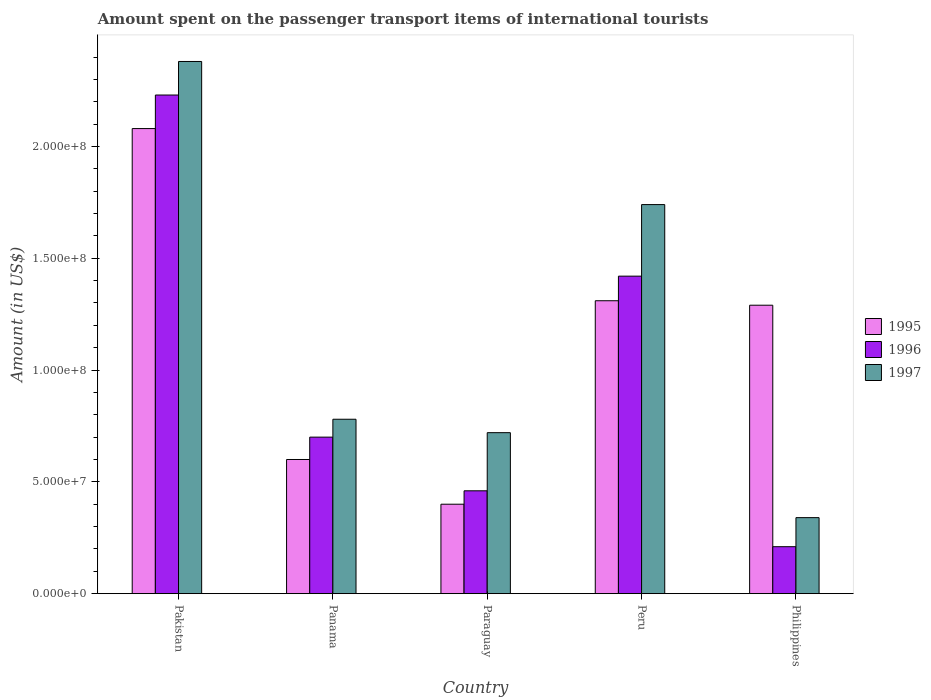How many different coloured bars are there?
Offer a very short reply. 3. Are the number of bars on each tick of the X-axis equal?
Make the answer very short. Yes. What is the label of the 3rd group of bars from the left?
Your response must be concise. Paraguay. In how many cases, is the number of bars for a given country not equal to the number of legend labels?
Your response must be concise. 0. What is the amount spent on the passenger transport items of international tourists in 1996 in Philippines?
Your answer should be very brief. 2.10e+07. Across all countries, what is the maximum amount spent on the passenger transport items of international tourists in 1996?
Ensure brevity in your answer.  2.23e+08. Across all countries, what is the minimum amount spent on the passenger transport items of international tourists in 1996?
Your answer should be very brief. 2.10e+07. What is the total amount spent on the passenger transport items of international tourists in 1995 in the graph?
Ensure brevity in your answer.  5.68e+08. What is the difference between the amount spent on the passenger transport items of international tourists in 1996 in Philippines and the amount spent on the passenger transport items of international tourists in 1995 in Pakistan?
Give a very brief answer. -1.87e+08. What is the average amount spent on the passenger transport items of international tourists in 1995 per country?
Your response must be concise. 1.14e+08. What is the difference between the amount spent on the passenger transport items of international tourists of/in 1997 and amount spent on the passenger transport items of international tourists of/in 1995 in Peru?
Provide a succinct answer. 4.30e+07. What is the ratio of the amount spent on the passenger transport items of international tourists in 1996 in Panama to that in Paraguay?
Your response must be concise. 1.52. Is the amount spent on the passenger transport items of international tourists in 1997 in Peru less than that in Philippines?
Your answer should be compact. No. Is the difference between the amount spent on the passenger transport items of international tourists in 1997 in Paraguay and Philippines greater than the difference between the amount spent on the passenger transport items of international tourists in 1995 in Paraguay and Philippines?
Provide a succinct answer. Yes. What is the difference between the highest and the second highest amount spent on the passenger transport items of international tourists in 1996?
Offer a very short reply. 1.53e+08. What is the difference between the highest and the lowest amount spent on the passenger transport items of international tourists in 1996?
Provide a short and direct response. 2.02e+08. In how many countries, is the amount spent on the passenger transport items of international tourists in 1996 greater than the average amount spent on the passenger transport items of international tourists in 1996 taken over all countries?
Make the answer very short. 2. Is it the case that in every country, the sum of the amount spent on the passenger transport items of international tourists in 1996 and amount spent on the passenger transport items of international tourists in 1997 is greater than the amount spent on the passenger transport items of international tourists in 1995?
Make the answer very short. No. Are all the bars in the graph horizontal?
Your response must be concise. No. Does the graph contain any zero values?
Your response must be concise. No. Does the graph contain grids?
Give a very brief answer. No. Where does the legend appear in the graph?
Your response must be concise. Center right. How many legend labels are there?
Your response must be concise. 3. What is the title of the graph?
Your answer should be very brief. Amount spent on the passenger transport items of international tourists. What is the label or title of the X-axis?
Make the answer very short. Country. What is the Amount (in US$) of 1995 in Pakistan?
Provide a short and direct response. 2.08e+08. What is the Amount (in US$) in 1996 in Pakistan?
Your response must be concise. 2.23e+08. What is the Amount (in US$) in 1997 in Pakistan?
Keep it short and to the point. 2.38e+08. What is the Amount (in US$) in 1995 in Panama?
Offer a terse response. 6.00e+07. What is the Amount (in US$) in 1996 in Panama?
Offer a terse response. 7.00e+07. What is the Amount (in US$) in 1997 in Panama?
Provide a short and direct response. 7.80e+07. What is the Amount (in US$) of 1995 in Paraguay?
Ensure brevity in your answer.  4.00e+07. What is the Amount (in US$) of 1996 in Paraguay?
Offer a terse response. 4.60e+07. What is the Amount (in US$) of 1997 in Paraguay?
Keep it short and to the point. 7.20e+07. What is the Amount (in US$) of 1995 in Peru?
Provide a short and direct response. 1.31e+08. What is the Amount (in US$) of 1996 in Peru?
Your response must be concise. 1.42e+08. What is the Amount (in US$) in 1997 in Peru?
Make the answer very short. 1.74e+08. What is the Amount (in US$) of 1995 in Philippines?
Your answer should be compact. 1.29e+08. What is the Amount (in US$) of 1996 in Philippines?
Give a very brief answer. 2.10e+07. What is the Amount (in US$) of 1997 in Philippines?
Give a very brief answer. 3.40e+07. Across all countries, what is the maximum Amount (in US$) in 1995?
Ensure brevity in your answer.  2.08e+08. Across all countries, what is the maximum Amount (in US$) of 1996?
Give a very brief answer. 2.23e+08. Across all countries, what is the maximum Amount (in US$) in 1997?
Your answer should be very brief. 2.38e+08. Across all countries, what is the minimum Amount (in US$) in 1995?
Provide a short and direct response. 4.00e+07. Across all countries, what is the minimum Amount (in US$) in 1996?
Your response must be concise. 2.10e+07. Across all countries, what is the minimum Amount (in US$) in 1997?
Provide a short and direct response. 3.40e+07. What is the total Amount (in US$) of 1995 in the graph?
Your answer should be very brief. 5.68e+08. What is the total Amount (in US$) in 1996 in the graph?
Provide a succinct answer. 5.02e+08. What is the total Amount (in US$) of 1997 in the graph?
Your answer should be very brief. 5.96e+08. What is the difference between the Amount (in US$) of 1995 in Pakistan and that in Panama?
Offer a terse response. 1.48e+08. What is the difference between the Amount (in US$) in 1996 in Pakistan and that in Panama?
Ensure brevity in your answer.  1.53e+08. What is the difference between the Amount (in US$) of 1997 in Pakistan and that in Panama?
Make the answer very short. 1.60e+08. What is the difference between the Amount (in US$) of 1995 in Pakistan and that in Paraguay?
Offer a very short reply. 1.68e+08. What is the difference between the Amount (in US$) in 1996 in Pakistan and that in Paraguay?
Offer a very short reply. 1.77e+08. What is the difference between the Amount (in US$) of 1997 in Pakistan and that in Paraguay?
Your answer should be compact. 1.66e+08. What is the difference between the Amount (in US$) of 1995 in Pakistan and that in Peru?
Offer a terse response. 7.70e+07. What is the difference between the Amount (in US$) of 1996 in Pakistan and that in Peru?
Ensure brevity in your answer.  8.10e+07. What is the difference between the Amount (in US$) in 1997 in Pakistan and that in Peru?
Provide a short and direct response. 6.40e+07. What is the difference between the Amount (in US$) of 1995 in Pakistan and that in Philippines?
Provide a succinct answer. 7.90e+07. What is the difference between the Amount (in US$) of 1996 in Pakistan and that in Philippines?
Offer a terse response. 2.02e+08. What is the difference between the Amount (in US$) in 1997 in Pakistan and that in Philippines?
Offer a very short reply. 2.04e+08. What is the difference between the Amount (in US$) in 1995 in Panama and that in Paraguay?
Ensure brevity in your answer.  2.00e+07. What is the difference between the Amount (in US$) of 1996 in Panama and that in Paraguay?
Ensure brevity in your answer.  2.40e+07. What is the difference between the Amount (in US$) in 1995 in Panama and that in Peru?
Your answer should be compact. -7.10e+07. What is the difference between the Amount (in US$) of 1996 in Panama and that in Peru?
Your answer should be compact. -7.20e+07. What is the difference between the Amount (in US$) of 1997 in Panama and that in Peru?
Provide a succinct answer. -9.60e+07. What is the difference between the Amount (in US$) in 1995 in Panama and that in Philippines?
Offer a very short reply. -6.90e+07. What is the difference between the Amount (in US$) of 1996 in Panama and that in Philippines?
Offer a terse response. 4.90e+07. What is the difference between the Amount (in US$) in 1997 in Panama and that in Philippines?
Offer a terse response. 4.40e+07. What is the difference between the Amount (in US$) of 1995 in Paraguay and that in Peru?
Ensure brevity in your answer.  -9.10e+07. What is the difference between the Amount (in US$) in 1996 in Paraguay and that in Peru?
Ensure brevity in your answer.  -9.60e+07. What is the difference between the Amount (in US$) in 1997 in Paraguay and that in Peru?
Provide a succinct answer. -1.02e+08. What is the difference between the Amount (in US$) of 1995 in Paraguay and that in Philippines?
Make the answer very short. -8.90e+07. What is the difference between the Amount (in US$) in 1996 in Paraguay and that in Philippines?
Make the answer very short. 2.50e+07. What is the difference between the Amount (in US$) of 1997 in Paraguay and that in Philippines?
Offer a very short reply. 3.80e+07. What is the difference between the Amount (in US$) in 1996 in Peru and that in Philippines?
Provide a succinct answer. 1.21e+08. What is the difference between the Amount (in US$) of 1997 in Peru and that in Philippines?
Keep it short and to the point. 1.40e+08. What is the difference between the Amount (in US$) in 1995 in Pakistan and the Amount (in US$) in 1996 in Panama?
Provide a short and direct response. 1.38e+08. What is the difference between the Amount (in US$) in 1995 in Pakistan and the Amount (in US$) in 1997 in Panama?
Offer a terse response. 1.30e+08. What is the difference between the Amount (in US$) of 1996 in Pakistan and the Amount (in US$) of 1997 in Panama?
Give a very brief answer. 1.45e+08. What is the difference between the Amount (in US$) of 1995 in Pakistan and the Amount (in US$) of 1996 in Paraguay?
Your response must be concise. 1.62e+08. What is the difference between the Amount (in US$) of 1995 in Pakistan and the Amount (in US$) of 1997 in Paraguay?
Your answer should be very brief. 1.36e+08. What is the difference between the Amount (in US$) of 1996 in Pakistan and the Amount (in US$) of 1997 in Paraguay?
Your answer should be compact. 1.51e+08. What is the difference between the Amount (in US$) in 1995 in Pakistan and the Amount (in US$) in 1996 in Peru?
Offer a very short reply. 6.60e+07. What is the difference between the Amount (in US$) of 1995 in Pakistan and the Amount (in US$) of 1997 in Peru?
Give a very brief answer. 3.40e+07. What is the difference between the Amount (in US$) of 1996 in Pakistan and the Amount (in US$) of 1997 in Peru?
Provide a short and direct response. 4.90e+07. What is the difference between the Amount (in US$) in 1995 in Pakistan and the Amount (in US$) in 1996 in Philippines?
Your answer should be compact. 1.87e+08. What is the difference between the Amount (in US$) in 1995 in Pakistan and the Amount (in US$) in 1997 in Philippines?
Your answer should be compact. 1.74e+08. What is the difference between the Amount (in US$) in 1996 in Pakistan and the Amount (in US$) in 1997 in Philippines?
Give a very brief answer. 1.89e+08. What is the difference between the Amount (in US$) of 1995 in Panama and the Amount (in US$) of 1996 in Paraguay?
Provide a succinct answer. 1.40e+07. What is the difference between the Amount (in US$) in 1995 in Panama and the Amount (in US$) in 1997 in Paraguay?
Offer a terse response. -1.20e+07. What is the difference between the Amount (in US$) in 1996 in Panama and the Amount (in US$) in 1997 in Paraguay?
Offer a very short reply. -2.00e+06. What is the difference between the Amount (in US$) of 1995 in Panama and the Amount (in US$) of 1996 in Peru?
Make the answer very short. -8.20e+07. What is the difference between the Amount (in US$) of 1995 in Panama and the Amount (in US$) of 1997 in Peru?
Keep it short and to the point. -1.14e+08. What is the difference between the Amount (in US$) in 1996 in Panama and the Amount (in US$) in 1997 in Peru?
Provide a succinct answer. -1.04e+08. What is the difference between the Amount (in US$) of 1995 in Panama and the Amount (in US$) of 1996 in Philippines?
Offer a very short reply. 3.90e+07. What is the difference between the Amount (in US$) in 1995 in Panama and the Amount (in US$) in 1997 in Philippines?
Give a very brief answer. 2.60e+07. What is the difference between the Amount (in US$) of 1996 in Panama and the Amount (in US$) of 1997 in Philippines?
Offer a very short reply. 3.60e+07. What is the difference between the Amount (in US$) of 1995 in Paraguay and the Amount (in US$) of 1996 in Peru?
Give a very brief answer. -1.02e+08. What is the difference between the Amount (in US$) in 1995 in Paraguay and the Amount (in US$) in 1997 in Peru?
Offer a terse response. -1.34e+08. What is the difference between the Amount (in US$) in 1996 in Paraguay and the Amount (in US$) in 1997 in Peru?
Ensure brevity in your answer.  -1.28e+08. What is the difference between the Amount (in US$) in 1995 in Paraguay and the Amount (in US$) in 1996 in Philippines?
Keep it short and to the point. 1.90e+07. What is the difference between the Amount (in US$) of 1995 in Paraguay and the Amount (in US$) of 1997 in Philippines?
Offer a very short reply. 6.00e+06. What is the difference between the Amount (in US$) in 1995 in Peru and the Amount (in US$) in 1996 in Philippines?
Your answer should be very brief. 1.10e+08. What is the difference between the Amount (in US$) in 1995 in Peru and the Amount (in US$) in 1997 in Philippines?
Ensure brevity in your answer.  9.70e+07. What is the difference between the Amount (in US$) in 1996 in Peru and the Amount (in US$) in 1997 in Philippines?
Your answer should be very brief. 1.08e+08. What is the average Amount (in US$) in 1995 per country?
Offer a terse response. 1.14e+08. What is the average Amount (in US$) of 1996 per country?
Your answer should be compact. 1.00e+08. What is the average Amount (in US$) of 1997 per country?
Your answer should be compact. 1.19e+08. What is the difference between the Amount (in US$) of 1995 and Amount (in US$) of 1996 in Pakistan?
Offer a terse response. -1.50e+07. What is the difference between the Amount (in US$) in 1995 and Amount (in US$) in 1997 in Pakistan?
Provide a succinct answer. -3.00e+07. What is the difference between the Amount (in US$) of 1996 and Amount (in US$) of 1997 in Pakistan?
Offer a very short reply. -1.50e+07. What is the difference between the Amount (in US$) of 1995 and Amount (in US$) of 1996 in Panama?
Keep it short and to the point. -1.00e+07. What is the difference between the Amount (in US$) in 1995 and Amount (in US$) in 1997 in Panama?
Offer a terse response. -1.80e+07. What is the difference between the Amount (in US$) of 1996 and Amount (in US$) of 1997 in Panama?
Your answer should be very brief. -8.00e+06. What is the difference between the Amount (in US$) in 1995 and Amount (in US$) in 1996 in Paraguay?
Keep it short and to the point. -6.00e+06. What is the difference between the Amount (in US$) of 1995 and Amount (in US$) of 1997 in Paraguay?
Give a very brief answer. -3.20e+07. What is the difference between the Amount (in US$) in 1996 and Amount (in US$) in 1997 in Paraguay?
Ensure brevity in your answer.  -2.60e+07. What is the difference between the Amount (in US$) of 1995 and Amount (in US$) of 1996 in Peru?
Provide a short and direct response. -1.10e+07. What is the difference between the Amount (in US$) of 1995 and Amount (in US$) of 1997 in Peru?
Provide a succinct answer. -4.30e+07. What is the difference between the Amount (in US$) in 1996 and Amount (in US$) in 1997 in Peru?
Give a very brief answer. -3.20e+07. What is the difference between the Amount (in US$) in 1995 and Amount (in US$) in 1996 in Philippines?
Make the answer very short. 1.08e+08. What is the difference between the Amount (in US$) in 1995 and Amount (in US$) in 1997 in Philippines?
Keep it short and to the point. 9.50e+07. What is the difference between the Amount (in US$) in 1996 and Amount (in US$) in 1997 in Philippines?
Keep it short and to the point. -1.30e+07. What is the ratio of the Amount (in US$) of 1995 in Pakistan to that in Panama?
Your answer should be compact. 3.47. What is the ratio of the Amount (in US$) of 1996 in Pakistan to that in Panama?
Give a very brief answer. 3.19. What is the ratio of the Amount (in US$) of 1997 in Pakistan to that in Panama?
Your answer should be very brief. 3.05. What is the ratio of the Amount (in US$) of 1996 in Pakistan to that in Paraguay?
Provide a short and direct response. 4.85. What is the ratio of the Amount (in US$) of 1997 in Pakistan to that in Paraguay?
Make the answer very short. 3.31. What is the ratio of the Amount (in US$) in 1995 in Pakistan to that in Peru?
Ensure brevity in your answer.  1.59. What is the ratio of the Amount (in US$) of 1996 in Pakistan to that in Peru?
Ensure brevity in your answer.  1.57. What is the ratio of the Amount (in US$) of 1997 in Pakistan to that in Peru?
Offer a very short reply. 1.37. What is the ratio of the Amount (in US$) in 1995 in Pakistan to that in Philippines?
Make the answer very short. 1.61. What is the ratio of the Amount (in US$) of 1996 in Pakistan to that in Philippines?
Make the answer very short. 10.62. What is the ratio of the Amount (in US$) in 1995 in Panama to that in Paraguay?
Provide a succinct answer. 1.5. What is the ratio of the Amount (in US$) in 1996 in Panama to that in Paraguay?
Your response must be concise. 1.52. What is the ratio of the Amount (in US$) of 1995 in Panama to that in Peru?
Give a very brief answer. 0.46. What is the ratio of the Amount (in US$) in 1996 in Panama to that in Peru?
Make the answer very short. 0.49. What is the ratio of the Amount (in US$) of 1997 in Panama to that in Peru?
Give a very brief answer. 0.45. What is the ratio of the Amount (in US$) of 1995 in Panama to that in Philippines?
Provide a short and direct response. 0.47. What is the ratio of the Amount (in US$) in 1996 in Panama to that in Philippines?
Make the answer very short. 3.33. What is the ratio of the Amount (in US$) of 1997 in Panama to that in Philippines?
Offer a very short reply. 2.29. What is the ratio of the Amount (in US$) in 1995 in Paraguay to that in Peru?
Your answer should be very brief. 0.31. What is the ratio of the Amount (in US$) in 1996 in Paraguay to that in Peru?
Give a very brief answer. 0.32. What is the ratio of the Amount (in US$) in 1997 in Paraguay to that in Peru?
Offer a terse response. 0.41. What is the ratio of the Amount (in US$) in 1995 in Paraguay to that in Philippines?
Your response must be concise. 0.31. What is the ratio of the Amount (in US$) in 1996 in Paraguay to that in Philippines?
Provide a short and direct response. 2.19. What is the ratio of the Amount (in US$) in 1997 in Paraguay to that in Philippines?
Provide a short and direct response. 2.12. What is the ratio of the Amount (in US$) in 1995 in Peru to that in Philippines?
Ensure brevity in your answer.  1.02. What is the ratio of the Amount (in US$) of 1996 in Peru to that in Philippines?
Offer a very short reply. 6.76. What is the ratio of the Amount (in US$) of 1997 in Peru to that in Philippines?
Provide a short and direct response. 5.12. What is the difference between the highest and the second highest Amount (in US$) of 1995?
Offer a terse response. 7.70e+07. What is the difference between the highest and the second highest Amount (in US$) in 1996?
Your answer should be very brief. 8.10e+07. What is the difference between the highest and the second highest Amount (in US$) of 1997?
Provide a short and direct response. 6.40e+07. What is the difference between the highest and the lowest Amount (in US$) of 1995?
Provide a short and direct response. 1.68e+08. What is the difference between the highest and the lowest Amount (in US$) of 1996?
Make the answer very short. 2.02e+08. What is the difference between the highest and the lowest Amount (in US$) in 1997?
Offer a very short reply. 2.04e+08. 